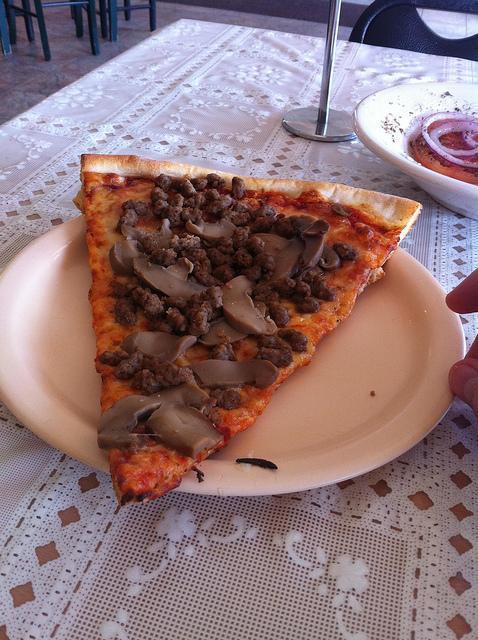Is this affirmation: "The bowl is left of the pizza." correct?
Answer yes or no. No. 